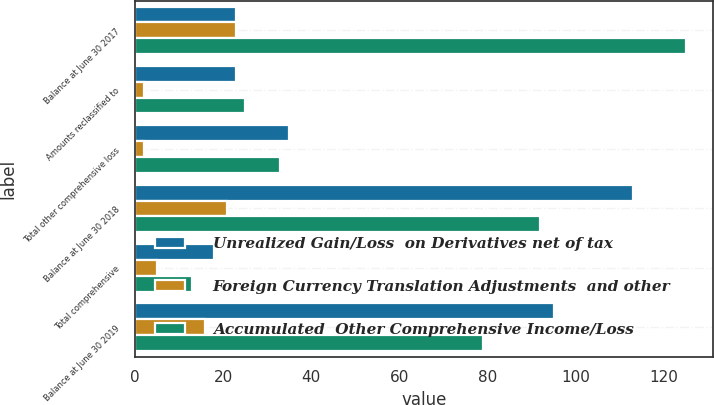Convert chart. <chart><loc_0><loc_0><loc_500><loc_500><stacked_bar_chart><ecel><fcel>Balance at June 30 2017<fcel>Amounts reclassified to<fcel>Total other comprehensive loss<fcel>Balance at June 30 2018<fcel>Total comprehensive<fcel>Balance at June 30 2019<nl><fcel>Unrealized Gain/Loss  on Derivatives net of tax<fcel>23<fcel>23<fcel>35<fcel>113<fcel>18<fcel>95<nl><fcel>Foreign Currency Translation Adjustments  and other<fcel>23<fcel>2<fcel>2<fcel>21<fcel>5<fcel>16<nl><fcel>Accumulated  Other Comprehensive Income/Loss<fcel>125<fcel>25<fcel>33<fcel>92<fcel>13<fcel>79<nl></chart> 